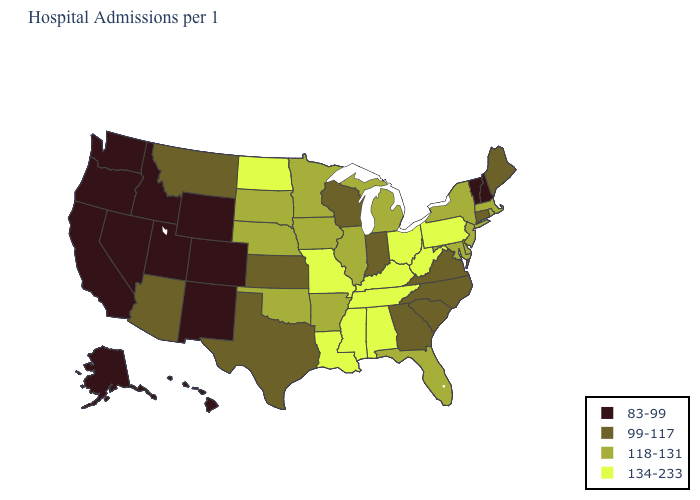Name the states that have a value in the range 134-233?
Concise answer only. Alabama, Kentucky, Louisiana, Mississippi, Missouri, North Dakota, Ohio, Pennsylvania, Tennessee, West Virginia. What is the value of South Carolina?
Write a very short answer. 99-117. Name the states that have a value in the range 118-131?
Concise answer only. Arkansas, Delaware, Florida, Illinois, Iowa, Maryland, Massachusetts, Michigan, Minnesota, Nebraska, New Jersey, New York, Oklahoma, Rhode Island, South Dakota. What is the value of Ohio?
Keep it brief. 134-233. Is the legend a continuous bar?
Answer briefly. No. Is the legend a continuous bar?
Answer briefly. No. Does the first symbol in the legend represent the smallest category?
Keep it brief. Yes. Name the states that have a value in the range 83-99?
Give a very brief answer. Alaska, California, Colorado, Hawaii, Idaho, Nevada, New Hampshire, New Mexico, Oregon, Utah, Vermont, Washington, Wyoming. What is the value of Colorado?
Be succinct. 83-99. What is the highest value in the West ?
Write a very short answer. 99-117. Name the states that have a value in the range 134-233?
Quick response, please. Alabama, Kentucky, Louisiana, Mississippi, Missouri, North Dakota, Ohio, Pennsylvania, Tennessee, West Virginia. Name the states that have a value in the range 83-99?
Keep it brief. Alaska, California, Colorado, Hawaii, Idaho, Nevada, New Hampshire, New Mexico, Oregon, Utah, Vermont, Washington, Wyoming. Does Kentucky have the same value as Mississippi?
Write a very short answer. Yes. Among the states that border Maryland , which have the highest value?
Be succinct. Pennsylvania, West Virginia. What is the lowest value in the USA?
Keep it brief. 83-99. 